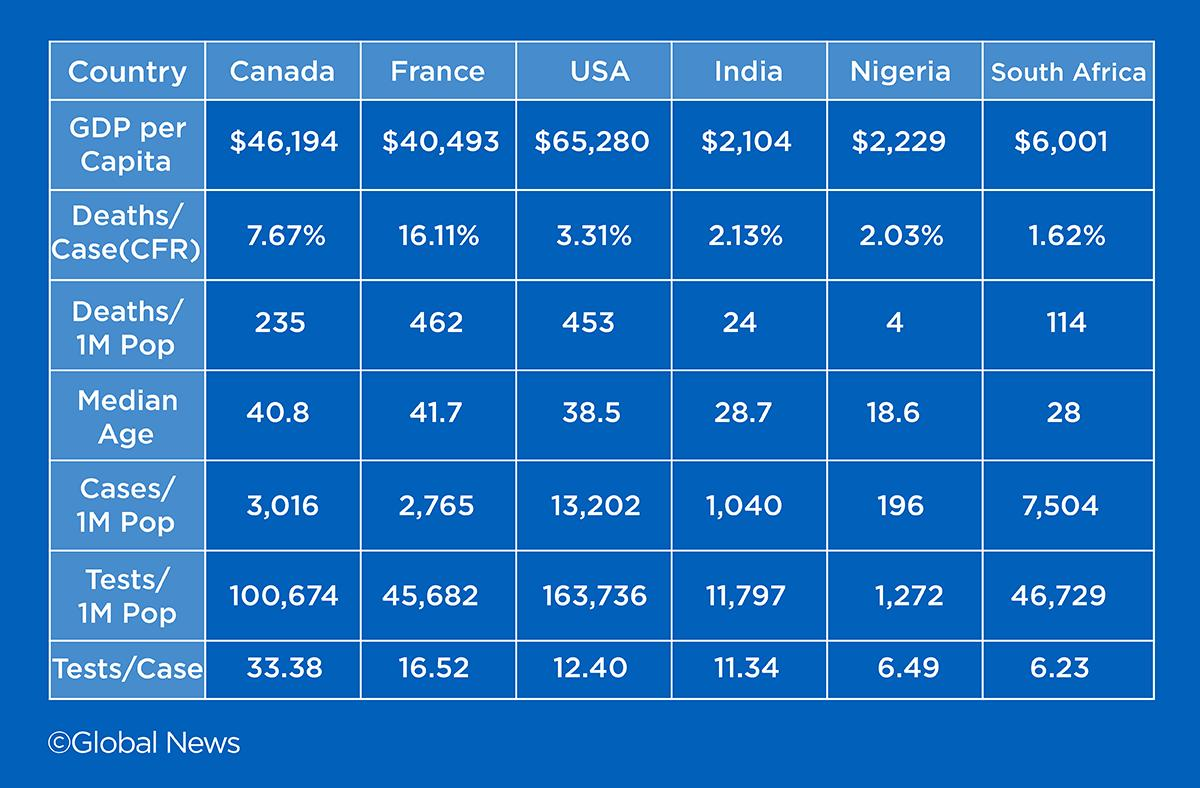Outline some significant characteristics in this image. In India, a total of 11.34 tests were conducted per case. In France, there were approximately 2,765 cases of a specific condition per one million population in 2021. India has the lowest GDP per capita among all countries. According to the given data, Canada has the second highest GDP per capita. The United States of America has reported the highest number of cases per one million population among all countries that have reported cases to the WHO. 